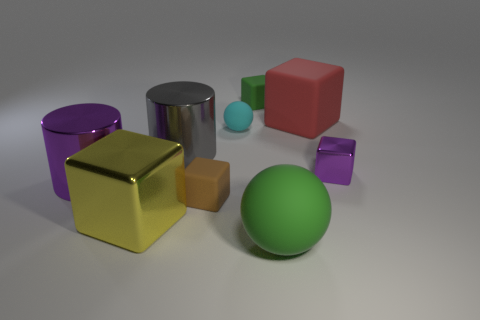Subtract all green cubes. How many cubes are left? 4 Subtract all brown cubes. How many cubes are left? 4 Add 1 large green matte cylinders. How many objects exist? 10 Subtract 1 balls. How many balls are left? 1 Subtract all cubes. How many objects are left? 4 Subtract all cyan balls. Subtract all cyan cylinders. How many balls are left? 1 Subtract all big yellow things. Subtract all gray shiny balls. How many objects are left? 8 Add 9 small green rubber cubes. How many small green rubber cubes are left? 10 Add 7 large gray metal cylinders. How many large gray metal cylinders exist? 8 Subtract 0 red spheres. How many objects are left? 9 